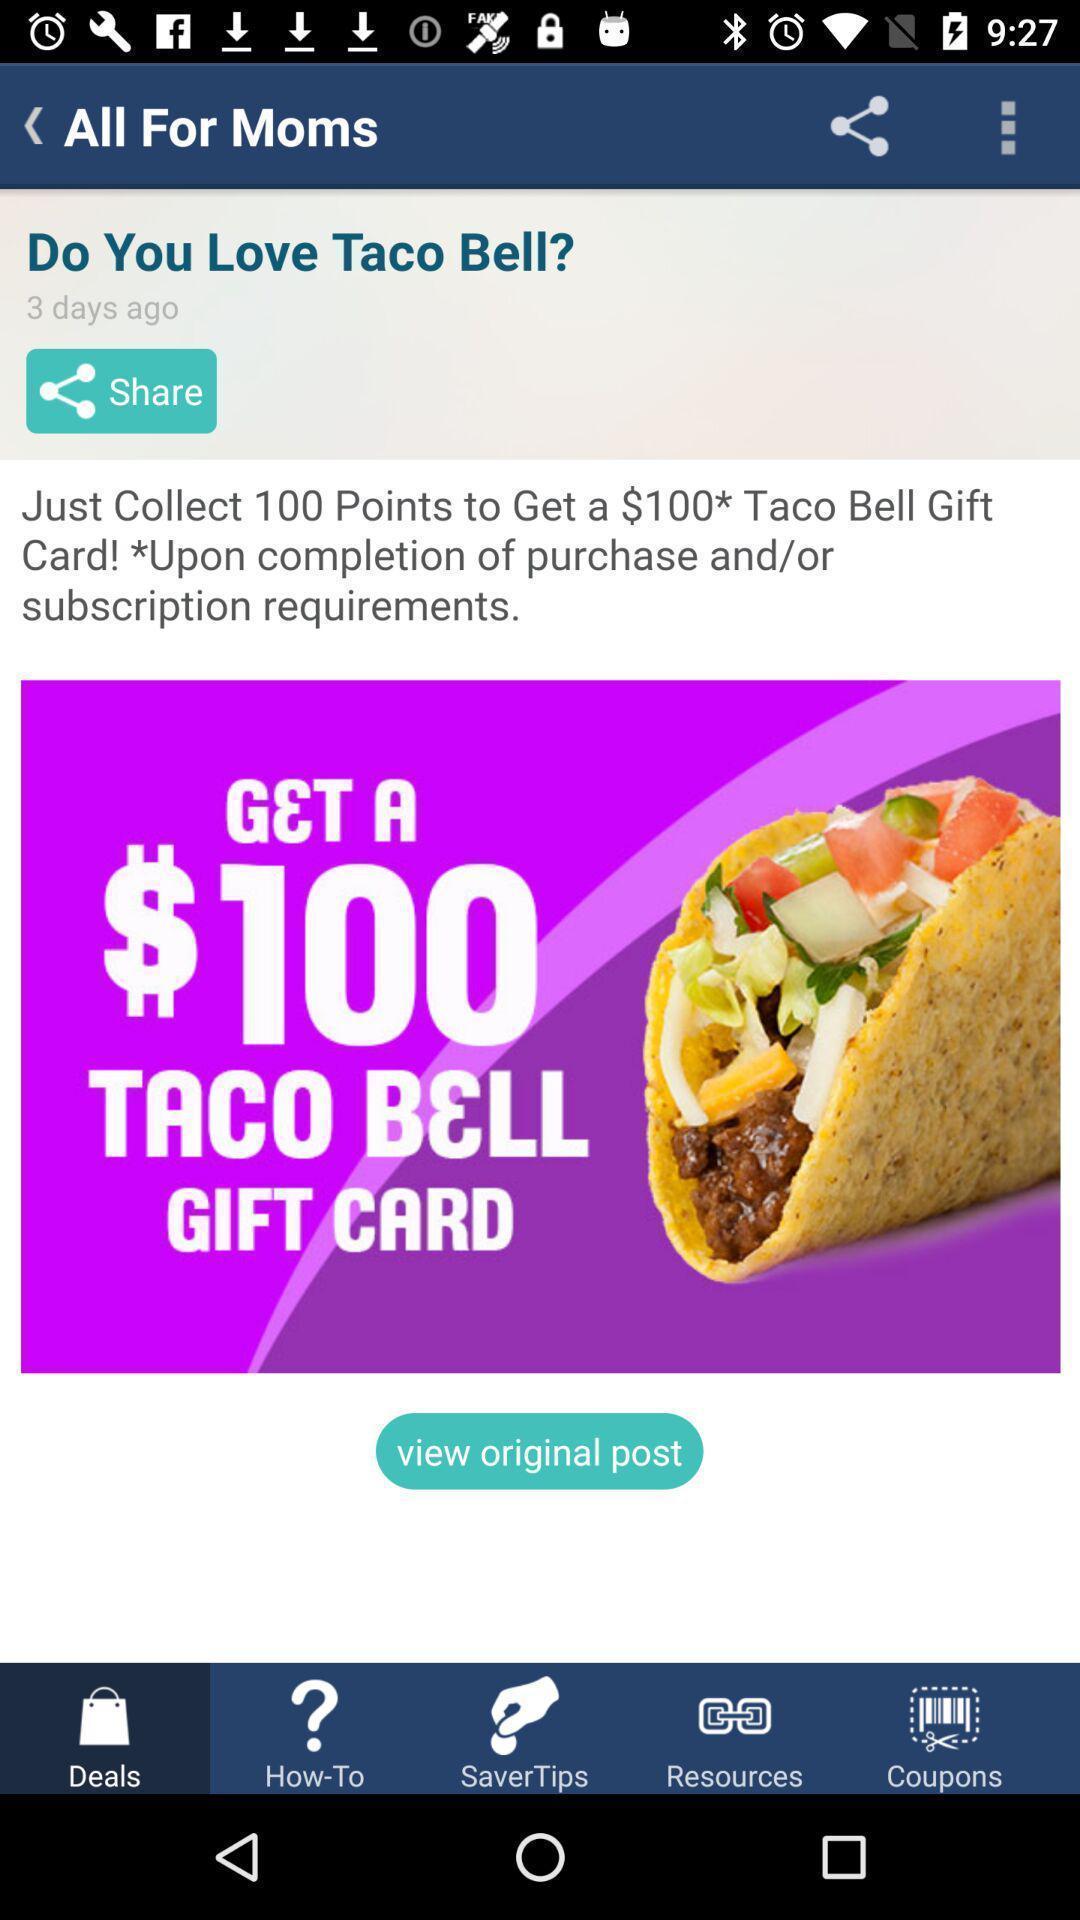Tell me what you see in this picture. Pages displays deals in app. 